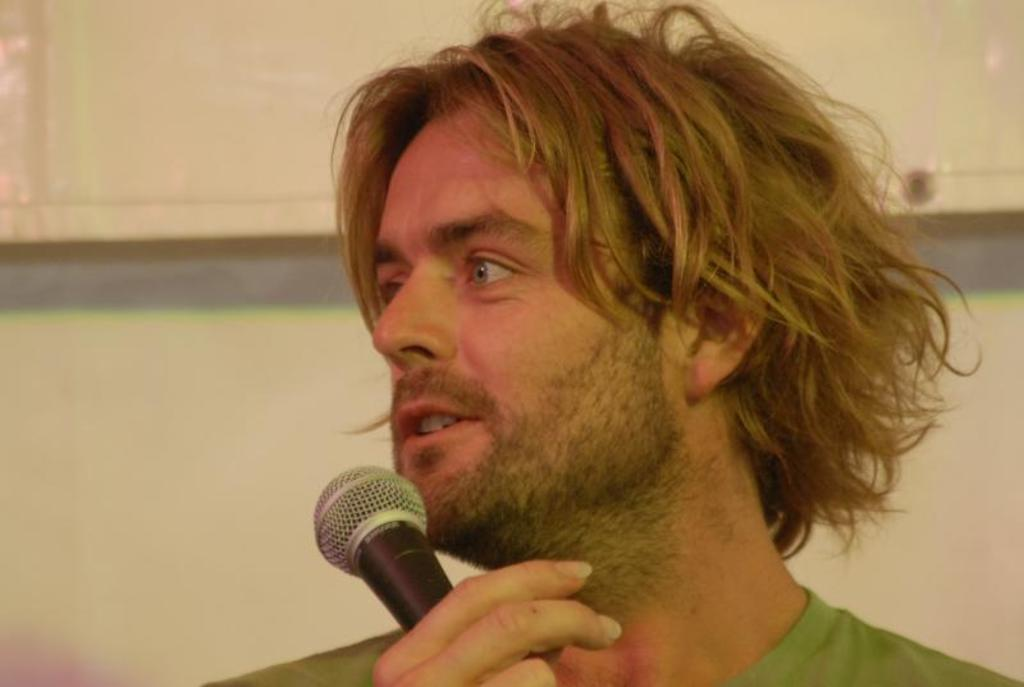Who is the main subject in the image? There is a man in the image. What is the man holding in the image? The man is holding a microphone. What color is the clothing the man is wearing? The man is wearing green-colored clothing. What can be seen in the background of the image? There is a wall in the background of the image. What type of jam is the man spreading on the sink in the image? There is no jam or sink present in the image; the man is holding a microphone and wearing green-colored clothing. 